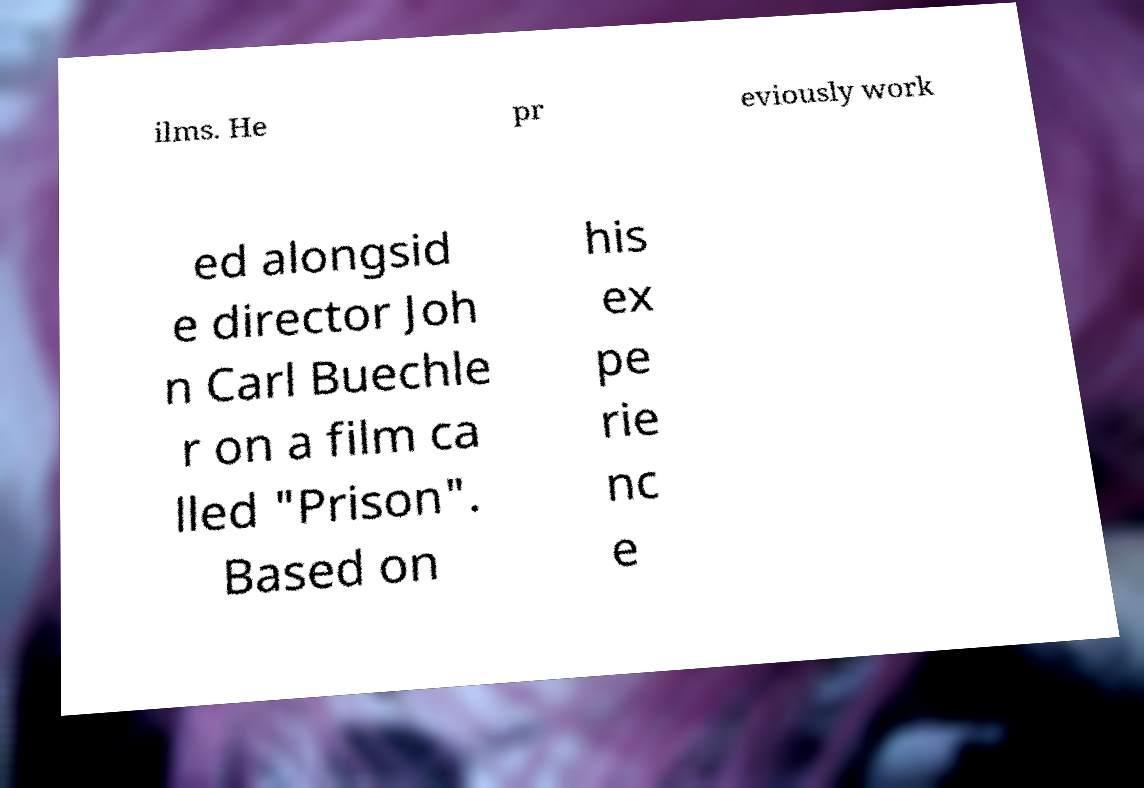Could you extract and type out the text from this image? ilms. He pr eviously work ed alongsid e director Joh n Carl Buechle r on a film ca lled "Prison". Based on his ex pe rie nc e 